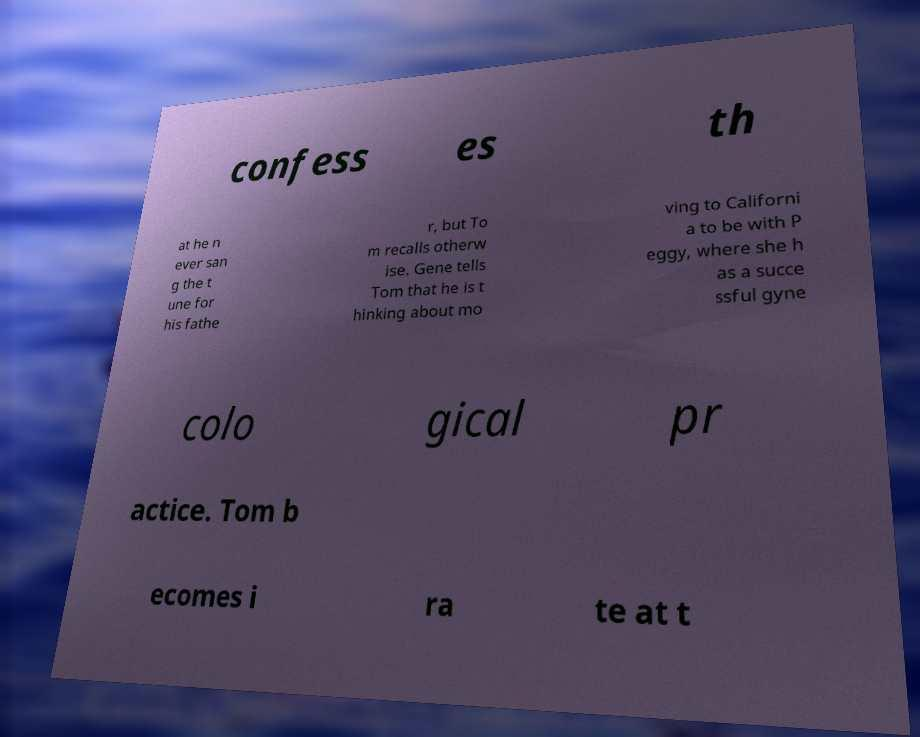I need the written content from this picture converted into text. Can you do that? confess es th at he n ever san g the t une for his fathe r, but To m recalls otherw ise. Gene tells Tom that he is t hinking about mo ving to Californi a to be with P eggy, where she h as a succe ssful gyne colo gical pr actice. Tom b ecomes i ra te at t 